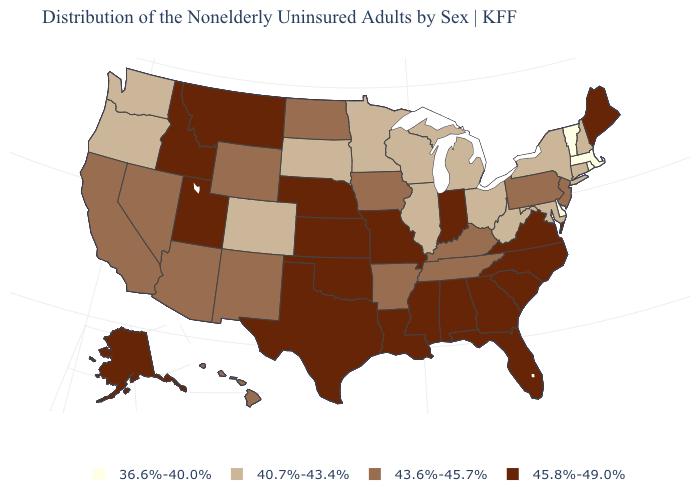What is the highest value in the USA?
Answer briefly. 45.8%-49.0%. What is the value of Illinois?
Answer briefly. 40.7%-43.4%. What is the lowest value in the MidWest?
Give a very brief answer. 40.7%-43.4%. Name the states that have a value in the range 36.6%-40.0%?
Concise answer only. Delaware, Massachusetts, Rhode Island, Vermont. Does Delaware have the lowest value in the USA?
Concise answer only. Yes. What is the highest value in states that border Tennessee?
Write a very short answer. 45.8%-49.0%. What is the value of South Carolina?
Write a very short answer. 45.8%-49.0%. What is the highest value in the USA?
Give a very brief answer. 45.8%-49.0%. Which states hav the highest value in the MidWest?
Concise answer only. Indiana, Kansas, Missouri, Nebraska. Name the states that have a value in the range 40.7%-43.4%?
Short answer required. Colorado, Connecticut, Illinois, Maryland, Michigan, Minnesota, New Hampshire, New York, Ohio, Oregon, South Dakota, Washington, West Virginia, Wisconsin. What is the value of Colorado?
Keep it brief. 40.7%-43.4%. Does Florida have the highest value in the USA?
Write a very short answer. Yes. Among the states that border Louisiana , which have the lowest value?
Keep it brief. Arkansas. Name the states that have a value in the range 43.6%-45.7%?
Concise answer only. Arizona, Arkansas, California, Hawaii, Iowa, Kentucky, Nevada, New Jersey, New Mexico, North Dakota, Pennsylvania, Tennessee, Wyoming. What is the highest value in the MidWest ?
Answer briefly. 45.8%-49.0%. 